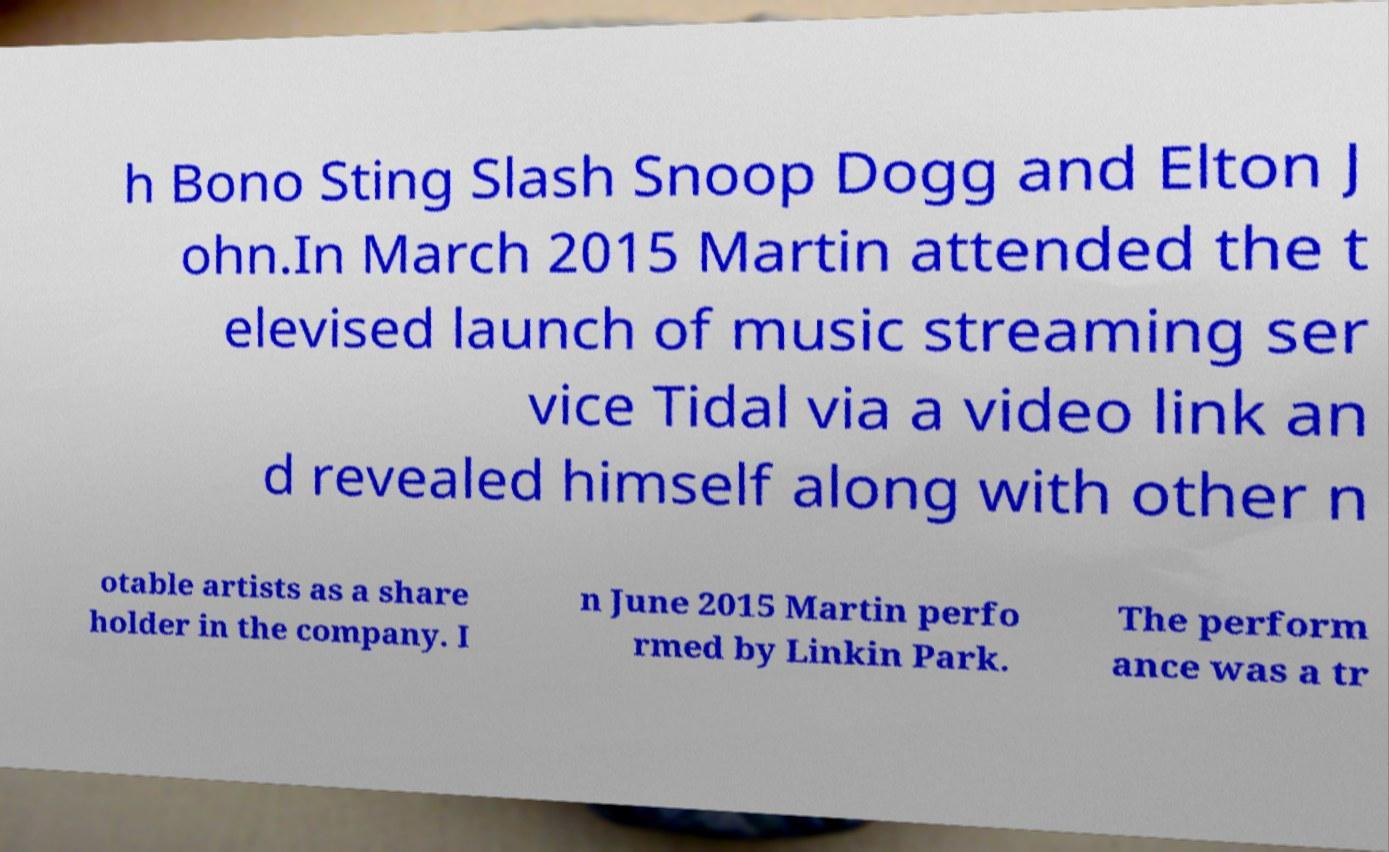Can you read and provide the text displayed in the image?This photo seems to have some interesting text. Can you extract and type it out for me? h Bono Sting Slash Snoop Dogg and Elton J ohn.In March 2015 Martin attended the t elevised launch of music streaming ser vice Tidal via a video link an d revealed himself along with other n otable artists as a share holder in the company. I n June 2015 Martin perfo rmed by Linkin Park. The perform ance was a tr 